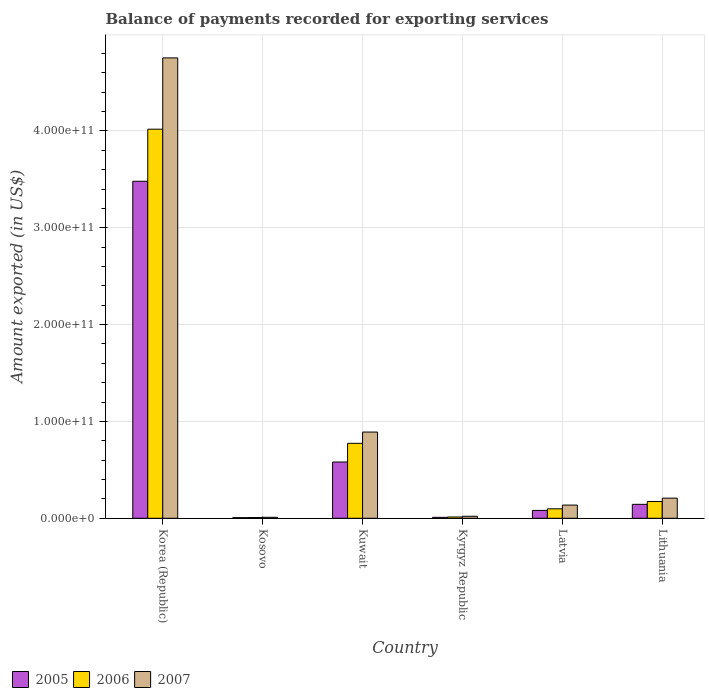How many different coloured bars are there?
Your answer should be compact. 3. Are the number of bars on each tick of the X-axis equal?
Keep it short and to the point. Yes. What is the label of the 3rd group of bars from the left?
Offer a very short reply. Kuwait. What is the amount exported in 2005 in Latvia?
Your response must be concise. 8.11e+09. Across all countries, what is the maximum amount exported in 2006?
Give a very brief answer. 4.02e+11. Across all countries, what is the minimum amount exported in 2006?
Your response must be concise. 7.50e+08. In which country was the amount exported in 2006 maximum?
Provide a succinct answer. Korea (Republic). In which country was the amount exported in 2007 minimum?
Your answer should be very brief. Kosovo. What is the total amount exported in 2006 in the graph?
Your answer should be compact. 5.08e+11. What is the difference between the amount exported in 2006 in Korea (Republic) and that in Lithuania?
Ensure brevity in your answer.  3.84e+11. What is the difference between the amount exported in 2006 in Kuwait and the amount exported in 2005 in Lithuania?
Ensure brevity in your answer.  6.30e+1. What is the average amount exported in 2007 per country?
Offer a very short reply. 1.00e+11. What is the difference between the amount exported of/in 2005 and amount exported of/in 2006 in Kosovo?
Keep it short and to the point. -1.26e+08. In how many countries, is the amount exported in 2005 greater than 300000000000 US$?
Provide a short and direct response. 1. What is the ratio of the amount exported in 2007 in Korea (Republic) to that in Latvia?
Provide a short and direct response. 34.93. Is the difference between the amount exported in 2005 in Korea (Republic) and Kuwait greater than the difference between the amount exported in 2006 in Korea (Republic) and Kuwait?
Ensure brevity in your answer.  No. What is the difference between the highest and the second highest amount exported in 2005?
Make the answer very short. 2.90e+11. What is the difference between the highest and the lowest amount exported in 2006?
Keep it short and to the point. 4.01e+11. In how many countries, is the amount exported in 2006 greater than the average amount exported in 2006 taken over all countries?
Provide a short and direct response. 1. Is the sum of the amount exported in 2007 in Korea (Republic) and Kyrgyz Republic greater than the maximum amount exported in 2006 across all countries?
Offer a terse response. Yes. What does the 3rd bar from the left in Kyrgyz Republic represents?
Give a very brief answer. 2007. What does the 2nd bar from the right in Kyrgyz Republic represents?
Give a very brief answer. 2006. How many countries are there in the graph?
Offer a terse response. 6. What is the difference between two consecutive major ticks on the Y-axis?
Give a very brief answer. 1.00e+11. Are the values on the major ticks of Y-axis written in scientific E-notation?
Your answer should be compact. Yes. Does the graph contain any zero values?
Your answer should be compact. No. Does the graph contain grids?
Offer a terse response. Yes. Where does the legend appear in the graph?
Provide a succinct answer. Bottom left. How many legend labels are there?
Your answer should be very brief. 3. What is the title of the graph?
Offer a very short reply. Balance of payments recorded for exporting services. Does "1990" appear as one of the legend labels in the graph?
Your response must be concise. No. What is the label or title of the Y-axis?
Keep it short and to the point. Amount exported (in US$). What is the Amount exported (in US$) of 2005 in Korea (Republic)?
Your answer should be very brief. 3.48e+11. What is the Amount exported (in US$) in 2006 in Korea (Republic)?
Your response must be concise. 4.02e+11. What is the Amount exported (in US$) in 2007 in Korea (Republic)?
Ensure brevity in your answer.  4.75e+11. What is the Amount exported (in US$) in 2005 in Kosovo?
Give a very brief answer. 6.25e+08. What is the Amount exported (in US$) of 2006 in Kosovo?
Make the answer very short. 7.50e+08. What is the Amount exported (in US$) of 2007 in Kosovo?
Make the answer very short. 9.91e+08. What is the Amount exported (in US$) of 2005 in Kuwait?
Offer a terse response. 5.81e+1. What is the Amount exported (in US$) in 2006 in Kuwait?
Your answer should be compact. 7.74e+1. What is the Amount exported (in US$) in 2007 in Kuwait?
Keep it short and to the point. 8.90e+1. What is the Amount exported (in US$) of 2005 in Kyrgyz Republic?
Make the answer very short. 9.63e+08. What is the Amount exported (in US$) in 2006 in Kyrgyz Republic?
Your answer should be compact. 1.33e+09. What is the Amount exported (in US$) in 2007 in Kyrgyz Republic?
Your answer should be compact. 2.07e+09. What is the Amount exported (in US$) in 2005 in Latvia?
Your answer should be compact. 8.11e+09. What is the Amount exported (in US$) of 2006 in Latvia?
Ensure brevity in your answer.  9.78e+09. What is the Amount exported (in US$) of 2007 in Latvia?
Your answer should be compact. 1.36e+1. What is the Amount exported (in US$) of 2005 in Lithuania?
Your answer should be very brief. 1.44e+1. What is the Amount exported (in US$) of 2006 in Lithuania?
Your response must be concise. 1.73e+1. What is the Amount exported (in US$) of 2007 in Lithuania?
Give a very brief answer. 2.08e+1. Across all countries, what is the maximum Amount exported (in US$) of 2005?
Keep it short and to the point. 3.48e+11. Across all countries, what is the maximum Amount exported (in US$) in 2006?
Offer a very short reply. 4.02e+11. Across all countries, what is the maximum Amount exported (in US$) of 2007?
Offer a terse response. 4.75e+11. Across all countries, what is the minimum Amount exported (in US$) in 2005?
Offer a terse response. 6.25e+08. Across all countries, what is the minimum Amount exported (in US$) of 2006?
Ensure brevity in your answer.  7.50e+08. Across all countries, what is the minimum Amount exported (in US$) of 2007?
Offer a very short reply. 9.91e+08. What is the total Amount exported (in US$) in 2005 in the graph?
Keep it short and to the point. 4.30e+11. What is the total Amount exported (in US$) of 2006 in the graph?
Offer a terse response. 5.08e+11. What is the total Amount exported (in US$) in 2007 in the graph?
Provide a short and direct response. 6.02e+11. What is the difference between the Amount exported (in US$) of 2005 in Korea (Republic) and that in Kosovo?
Give a very brief answer. 3.47e+11. What is the difference between the Amount exported (in US$) in 2006 in Korea (Republic) and that in Kosovo?
Your answer should be very brief. 4.01e+11. What is the difference between the Amount exported (in US$) of 2007 in Korea (Republic) and that in Kosovo?
Ensure brevity in your answer.  4.74e+11. What is the difference between the Amount exported (in US$) of 2005 in Korea (Republic) and that in Kuwait?
Your answer should be compact. 2.90e+11. What is the difference between the Amount exported (in US$) of 2006 in Korea (Republic) and that in Kuwait?
Your answer should be compact. 3.24e+11. What is the difference between the Amount exported (in US$) in 2007 in Korea (Republic) and that in Kuwait?
Make the answer very short. 3.86e+11. What is the difference between the Amount exported (in US$) in 2005 in Korea (Republic) and that in Kyrgyz Republic?
Keep it short and to the point. 3.47e+11. What is the difference between the Amount exported (in US$) in 2006 in Korea (Republic) and that in Kyrgyz Republic?
Offer a terse response. 4.00e+11. What is the difference between the Amount exported (in US$) in 2007 in Korea (Republic) and that in Kyrgyz Republic?
Your answer should be very brief. 4.73e+11. What is the difference between the Amount exported (in US$) of 2005 in Korea (Republic) and that in Latvia?
Your response must be concise. 3.40e+11. What is the difference between the Amount exported (in US$) in 2006 in Korea (Republic) and that in Latvia?
Ensure brevity in your answer.  3.92e+11. What is the difference between the Amount exported (in US$) of 2007 in Korea (Republic) and that in Latvia?
Offer a terse response. 4.62e+11. What is the difference between the Amount exported (in US$) of 2005 in Korea (Republic) and that in Lithuania?
Keep it short and to the point. 3.34e+11. What is the difference between the Amount exported (in US$) of 2006 in Korea (Republic) and that in Lithuania?
Offer a very short reply. 3.84e+11. What is the difference between the Amount exported (in US$) in 2007 in Korea (Republic) and that in Lithuania?
Give a very brief answer. 4.55e+11. What is the difference between the Amount exported (in US$) of 2005 in Kosovo and that in Kuwait?
Ensure brevity in your answer.  -5.75e+1. What is the difference between the Amount exported (in US$) in 2006 in Kosovo and that in Kuwait?
Provide a succinct answer. -7.66e+1. What is the difference between the Amount exported (in US$) of 2007 in Kosovo and that in Kuwait?
Ensure brevity in your answer.  -8.80e+1. What is the difference between the Amount exported (in US$) in 2005 in Kosovo and that in Kyrgyz Republic?
Your answer should be very brief. -3.38e+08. What is the difference between the Amount exported (in US$) of 2006 in Kosovo and that in Kyrgyz Republic?
Your answer should be compact. -5.76e+08. What is the difference between the Amount exported (in US$) in 2007 in Kosovo and that in Kyrgyz Republic?
Your answer should be compact. -1.07e+09. What is the difference between the Amount exported (in US$) in 2005 in Kosovo and that in Latvia?
Give a very brief answer. -7.49e+09. What is the difference between the Amount exported (in US$) of 2006 in Kosovo and that in Latvia?
Offer a terse response. -9.03e+09. What is the difference between the Amount exported (in US$) of 2007 in Kosovo and that in Latvia?
Provide a short and direct response. -1.26e+1. What is the difference between the Amount exported (in US$) of 2005 in Kosovo and that in Lithuania?
Your response must be concise. -1.38e+1. What is the difference between the Amount exported (in US$) in 2006 in Kosovo and that in Lithuania?
Your answer should be compact. -1.66e+1. What is the difference between the Amount exported (in US$) of 2007 in Kosovo and that in Lithuania?
Ensure brevity in your answer.  -1.98e+1. What is the difference between the Amount exported (in US$) in 2005 in Kuwait and that in Kyrgyz Republic?
Provide a short and direct response. 5.71e+1. What is the difference between the Amount exported (in US$) of 2006 in Kuwait and that in Kyrgyz Republic?
Ensure brevity in your answer.  7.61e+1. What is the difference between the Amount exported (in US$) of 2007 in Kuwait and that in Kyrgyz Republic?
Your answer should be very brief. 8.70e+1. What is the difference between the Amount exported (in US$) of 2005 in Kuwait and that in Latvia?
Offer a terse response. 5.00e+1. What is the difference between the Amount exported (in US$) in 2006 in Kuwait and that in Latvia?
Your answer should be compact. 6.76e+1. What is the difference between the Amount exported (in US$) in 2007 in Kuwait and that in Latvia?
Keep it short and to the point. 7.54e+1. What is the difference between the Amount exported (in US$) of 2005 in Kuwait and that in Lithuania?
Provide a succinct answer. 4.37e+1. What is the difference between the Amount exported (in US$) of 2006 in Kuwait and that in Lithuania?
Ensure brevity in your answer.  6.00e+1. What is the difference between the Amount exported (in US$) of 2007 in Kuwait and that in Lithuania?
Your answer should be very brief. 6.82e+1. What is the difference between the Amount exported (in US$) of 2005 in Kyrgyz Republic and that in Latvia?
Make the answer very short. -7.15e+09. What is the difference between the Amount exported (in US$) of 2006 in Kyrgyz Republic and that in Latvia?
Your answer should be compact. -8.45e+09. What is the difference between the Amount exported (in US$) of 2007 in Kyrgyz Republic and that in Latvia?
Provide a succinct answer. -1.15e+1. What is the difference between the Amount exported (in US$) in 2005 in Kyrgyz Republic and that in Lithuania?
Your response must be concise. -1.34e+1. What is the difference between the Amount exported (in US$) in 2006 in Kyrgyz Republic and that in Lithuania?
Ensure brevity in your answer.  -1.60e+1. What is the difference between the Amount exported (in US$) of 2007 in Kyrgyz Republic and that in Lithuania?
Give a very brief answer. -1.87e+1. What is the difference between the Amount exported (in US$) in 2005 in Latvia and that in Lithuania?
Your answer should be compact. -6.28e+09. What is the difference between the Amount exported (in US$) of 2006 in Latvia and that in Lithuania?
Provide a short and direct response. -7.57e+09. What is the difference between the Amount exported (in US$) of 2007 in Latvia and that in Lithuania?
Your response must be concise. -7.17e+09. What is the difference between the Amount exported (in US$) in 2005 in Korea (Republic) and the Amount exported (in US$) in 2006 in Kosovo?
Ensure brevity in your answer.  3.47e+11. What is the difference between the Amount exported (in US$) of 2005 in Korea (Republic) and the Amount exported (in US$) of 2007 in Kosovo?
Offer a terse response. 3.47e+11. What is the difference between the Amount exported (in US$) in 2006 in Korea (Republic) and the Amount exported (in US$) in 2007 in Kosovo?
Provide a succinct answer. 4.01e+11. What is the difference between the Amount exported (in US$) in 2005 in Korea (Republic) and the Amount exported (in US$) in 2006 in Kuwait?
Make the answer very short. 2.71e+11. What is the difference between the Amount exported (in US$) of 2005 in Korea (Republic) and the Amount exported (in US$) of 2007 in Kuwait?
Provide a succinct answer. 2.59e+11. What is the difference between the Amount exported (in US$) of 2006 in Korea (Republic) and the Amount exported (in US$) of 2007 in Kuwait?
Provide a short and direct response. 3.13e+11. What is the difference between the Amount exported (in US$) in 2005 in Korea (Republic) and the Amount exported (in US$) in 2006 in Kyrgyz Republic?
Make the answer very short. 3.47e+11. What is the difference between the Amount exported (in US$) in 2005 in Korea (Republic) and the Amount exported (in US$) in 2007 in Kyrgyz Republic?
Provide a succinct answer. 3.46e+11. What is the difference between the Amount exported (in US$) in 2006 in Korea (Republic) and the Amount exported (in US$) in 2007 in Kyrgyz Republic?
Your answer should be very brief. 4.00e+11. What is the difference between the Amount exported (in US$) of 2005 in Korea (Republic) and the Amount exported (in US$) of 2006 in Latvia?
Your response must be concise. 3.38e+11. What is the difference between the Amount exported (in US$) in 2005 in Korea (Republic) and the Amount exported (in US$) in 2007 in Latvia?
Your answer should be compact. 3.34e+11. What is the difference between the Amount exported (in US$) in 2006 in Korea (Republic) and the Amount exported (in US$) in 2007 in Latvia?
Offer a terse response. 3.88e+11. What is the difference between the Amount exported (in US$) of 2005 in Korea (Republic) and the Amount exported (in US$) of 2006 in Lithuania?
Your response must be concise. 3.31e+11. What is the difference between the Amount exported (in US$) of 2005 in Korea (Republic) and the Amount exported (in US$) of 2007 in Lithuania?
Your response must be concise. 3.27e+11. What is the difference between the Amount exported (in US$) in 2006 in Korea (Republic) and the Amount exported (in US$) in 2007 in Lithuania?
Your answer should be very brief. 3.81e+11. What is the difference between the Amount exported (in US$) in 2005 in Kosovo and the Amount exported (in US$) in 2006 in Kuwait?
Offer a terse response. -7.68e+1. What is the difference between the Amount exported (in US$) in 2005 in Kosovo and the Amount exported (in US$) in 2007 in Kuwait?
Keep it short and to the point. -8.84e+1. What is the difference between the Amount exported (in US$) of 2006 in Kosovo and the Amount exported (in US$) of 2007 in Kuwait?
Provide a succinct answer. -8.83e+1. What is the difference between the Amount exported (in US$) of 2005 in Kosovo and the Amount exported (in US$) of 2006 in Kyrgyz Republic?
Provide a short and direct response. -7.02e+08. What is the difference between the Amount exported (in US$) of 2005 in Kosovo and the Amount exported (in US$) of 2007 in Kyrgyz Republic?
Give a very brief answer. -1.44e+09. What is the difference between the Amount exported (in US$) of 2006 in Kosovo and the Amount exported (in US$) of 2007 in Kyrgyz Republic?
Make the answer very short. -1.31e+09. What is the difference between the Amount exported (in US$) in 2005 in Kosovo and the Amount exported (in US$) in 2006 in Latvia?
Offer a very short reply. -9.16e+09. What is the difference between the Amount exported (in US$) of 2005 in Kosovo and the Amount exported (in US$) of 2007 in Latvia?
Keep it short and to the point. -1.30e+1. What is the difference between the Amount exported (in US$) of 2006 in Kosovo and the Amount exported (in US$) of 2007 in Latvia?
Ensure brevity in your answer.  -1.29e+1. What is the difference between the Amount exported (in US$) in 2005 in Kosovo and the Amount exported (in US$) in 2006 in Lithuania?
Your answer should be very brief. -1.67e+1. What is the difference between the Amount exported (in US$) of 2005 in Kosovo and the Amount exported (in US$) of 2007 in Lithuania?
Provide a succinct answer. -2.02e+1. What is the difference between the Amount exported (in US$) in 2006 in Kosovo and the Amount exported (in US$) in 2007 in Lithuania?
Provide a short and direct response. -2.00e+1. What is the difference between the Amount exported (in US$) of 2005 in Kuwait and the Amount exported (in US$) of 2006 in Kyrgyz Republic?
Your response must be concise. 5.68e+1. What is the difference between the Amount exported (in US$) of 2005 in Kuwait and the Amount exported (in US$) of 2007 in Kyrgyz Republic?
Your answer should be very brief. 5.60e+1. What is the difference between the Amount exported (in US$) of 2006 in Kuwait and the Amount exported (in US$) of 2007 in Kyrgyz Republic?
Offer a terse response. 7.53e+1. What is the difference between the Amount exported (in US$) of 2005 in Kuwait and the Amount exported (in US$) of 2006 in Latvia?
Provide a short and direct response. 4.83e+1. What is the difference between the Amount exported (in US$) of 2005 in Kuwait and the Amount exported (in US$) of 2007 in Latvia?
Provide a succinct answer. 4.45e+1. What is the difference between the Amount exported (in US$) of 2006 in Kuwait and the Amount exported (in US$) of 2007 in Latvia?
Offer a very short reply. 6.38e+1. What is the difference between the Amount exported (in US$) in 2005 in Kuwait and the Amount exported (in US$) in 2006 in Lithuania?
Give a very brief answer. 4.08e+1. What is the difference between the Amount exported (in US$) of 2005 in Kuwait and the Amount exported (in US$) of 2007 in Lithuania?
Offer a terse response. 3.73e+1. What is the difference between the Amount exported (in US$) of 2006 in Kuwait and the Amount exported (in US$) of 2007 in Lithuania?
Your answer should be compact. 5.66e+1. What is the difference between the Amount exported (in US$) in 2005 in Kyrgyz Republic and the Amount exported (in US$) in 2006 in Latvia?
Ensure brevity in your answer.  -8.82e+09. What is the difference between the Amount exported (in US$) in 2005 in Kyrgyz Republic and the Amount exported (in US$) in 2007 in Latvia?
Provide a short and direct response. -1.26e+1. What is the difference between the Amount exported (in US$) in 2006 in Kyrgyz Republic and the Amount exported (in US$) in 2007 in Latvia?
Your response must be concise. -1.23e+1. What is the difference between the Amount exported (in US$) of 2005 in Kyrgyz Republic and the Amount exported (in US$) of 2006 in Lithuania?
Provide a succinct answer. -1.64e+1. What is the difference between the Amount exported (in US$) of 2005 in Kyrgyz Republic and the Amount exported (in US$) of 2007 in Lithuania?
Ensure brevity in your answer.  -1.98e+1. What is the difference between the Amount exported (in US$) of 2006 in Kyrgyz Republic and the Amount exported (in US$) of 2007 in Lithuania?
Ensure brevity in your answer.  -1.95e+1. What is the difference between the Amount exported (in US$) in 2005 in Latvia and the Amount exported (in US$) in 2006 in Lithuania?
Offer a very short reply. -9.24e+09. What is the difference between the Amount exported (in US$) of 2005 in Latvia and the Amount exported (in US$) of 2007 in Lithuania?
Offer a very short reply. -1.27e+1. What is the difference between the Amount exported (in US$) in 2006 in Latvia and the Amount exported (in US$) in 2007 in Lithuania?
Offer a terse response. -1.10e+1. What is the average Amount exported (in US$) in 2005 per country?
Your response must be concise. 7.17e+1. What is the average Amount exported (in US$) in 2006 per country?
Ensure brevity in your answer.  8.47e+1. What is the average Amount exported (in US$) in 2007 per country?
Your answer should be very brief. 1.00e+11. What is the difference between the Amount exported (in US$) of 2005 and Amount exported (in US$) of 2006 in Korea (Republic)?
Provide a short and direct response. -5.38e+1. What is the difference between the Amount exported (in US$) of 2005 and Amount exported (in US$) of 2007 in Korea (Republic)?
Ensure brevity in your answer.  -1.27e+11. What is the difference between the Amount exported (in US$) in 2006 and Amount exported (in US$) in 2007 in Korea (Republic)?
Keep it short and to the point. -7.36e+1. What is the difference between the Amount exported (in US$) in 2005 and Amount exported (in US$) in 2006 in Kosovo?
Offer a terse response. -1.26e+08. What is the difference between the Amount exported (in US$) of 2005 and Amount exported (in US$) of 2007 in Kosovo?
Provide a succinct answer. -3.66e+08. What is the difference between the Amount exported (in US$) of 2006 and Amount exported (in US$) of 2007 in Kosovo?
Provide a succinct answer. -2.40e+08. What is the difference between the Amount exported (in US$) in 2005 and Amount exported (in US$) in 2006 in Kuwait?
Make the answer very short. -1.93e+1. What is the difference between the Amount exported (in US$) of 2005 and Amount exported (in US$) of 2007 in Kuwait?
Offer a very short reply. -3.09e+1. What is the difference between the Amount exported (in US$) of 2006 and Amount exported (in US$) of 2007 in Kuwait?
Your answer should be very brief. -1.16e+1. What is the difference between the Amount exported (in US$) in 2005 and Amount exported (in US$) in 2006 in Kyrgyz Republic?
Make the answer very short. -3.64e+08. What is the difference between the Amount exported (in US$) of 2005 and Amount exported (in US$) of 2007 in Kyrgyz Republic?
Keep it short and to the point. -1.10e+09. What is the difference between the Amount exported (in US$) of 2006 and Amount exported (in US$) of 2007 in Kyrgyz Republic?
Make the answer very short. -7.39e+08. What is the difference between the Amount exported (in US$) of 2005 and Amount exported (in US$) of 2006 in Latvia?
Make the answer very short. -1.67e+09. What is the difference between the Amount exported (in US$) in 2005 and Amount exported (in US$) in 2007 in Latvia?
Provide a succinct answer. -5.50e+09. What is the difference between the Amount exported (in US$) in 2006 and Amount exported (in US$) in 2007 in Latvia?
Provide a short and direct response. -3.83e+09. What is the difference between the Amount exported (in US$) of 2005 and Amount exported (in US$) of 2006 in Lithuania?
Keep it short and to the point. -2.96e+09. What is the difference between the Amount exported (in US$) of 2005 and Amount exported (in US$) of 2007 in Lithuania?
Make the answer very short. -6.39e+09. What is the difference between the Amount exported (in US$) of 2006 and Amount exported (in US$) of 2007 in Lithuania?
Give a very brief answer. -3.43e+09. What is the ratio of the Amount exported (in US$) of 2005 in Korea (Republic) to that in Kosovo?
Your answer should be compact. 556.95. What is the ratio of the Amount exported (in US$) of 2006 in Korea (Republic) to that in Kosovo?
Your answer should be compact. 535.36. What is the ratio of the Amount exported (in US$) in 2007 in Korea (Republic) to that in Kosovo?
Offer a terse response. 479.9. What is the ratio of the Amount exported (in US$) of 2005 in Korea (Republic) to that in Kuwait?
Your answer should be compact. 5.99. What is the ratio of the Amount exported (in US$) in 2006 in Korea (Republic) to that in Kuwait?
Your response must be concise. 5.19. What is the ratio of the Amount exported (in US$) of 2007 in Korea (Republic) to that in Kuwait?
Make the answer very short. 5.34. What is the ratio of the Amount exported (in US$) in 2005 in Korea (Republic) to that in Kyrgyz Republic?
Your answer should be very brief. 361.44. What is the ratio of the Amount exported (in US$) of 2006 in Korea (Republic) to that in Kyrgyz Republic?
Ensure brevity in your answer.  302.91. What is the ratio of the Amount exported (in US$) of 2007 in Korea (Republic) to that in Kyrgyz Republic?
Ensure brevity in your answer.  230.19. What is the ratio of the Amount exported (in US$) of 2005 in Korea (Republic) to that in Latvia?
Your answer should be very brief. 42.9. What is the ratio of the Amount exported (in US$) in 2006 in Korea (Republic) to that in Latvia?
Keep it short and to the point. 41.08. What is the ratio of the Amount exported (in US$) in 2007 in Korea (Republic) to that in Latvia?
Make the answer very short. 34.93. What is the ratio of the Amount exported (in US$) of 2005 in Korea (Republic) to that in Lithuania?
Your answer should be compact. 24.19. What is the ratio of the Amount exported (in US$) of 2006 in Korea (Republic) to that in Lithuania?
Provide a short and direct response. 23.16. What is the ratio of the Amount exported (in US$) in 2007 in Korea (Republic) to that in Lithuania?
Give a very brief answer. 22.88. What is the ratio of the Amount exported (in US$) in 2005 in Kosovo to that in Kuwait?
Give a very brief answer. 0.01. What is the ratio of the Amount exported (in US$) in 2006 in Kosovo to that in Kuwait?
Your answer should be compact. 0.01. What is the ratio of the Amount exported (in US$) of 2007 in Kosovo to that in Kuwait?
Keep it short and to the point. 0.01. What is the ratio of the Amount exported (in US$) of 2005 in Kosovo to that in Kyrgyz Republic?
Make the answer very short. 0.65. What is the ratio of the Amount exported (in US$) in 2006 in Kosovo to that in Kyrgyz Republic?
Offer a very short reply. 0.57. What is the ratio of the Amount exported (in US$) of 2007 in Kosovo to that in Kyrgyz Republic?
Provide a succinct answer. 0.48. What is the ratio of the Amount exported (in US$) of 2005 in Kosovo to that in Latvia?
Offer a terse response. 0.08. What is the ratio of the Amount exported (in US$) of 2006 in Kosovo to that in Latvia?
Provide a short and direct response. 0.08. What is the ratio of the Amount exported (in US$) of 2007 in Kosovo to that in Latvia?
Provide a short and direct response. 0.07. What is the ratio of the Amount exported (in US$) in 2005 in Kosovo to that in Lithuania?
Your answer should be very brief. 0.04. What is the ratio of the Amount exported (in US$) in 2006 in Kosovo to that in Lithuania?
Provide a succinct answer. 0.04. What is the ratio of the Amount exported (in US$) of 2007 in Kosovo to that in Lithuania?
Your answer should be compact. 0.05. What is the ratio of the Amount exported (in US$) of 2005 in Kuwait to that in Kyrgyz Republic?
Provide a succinct answer. 60.35. What is the ratio of the Amount exported (in US$) of 2006 in Kuwait to that in Kyrgyz Republic?
Provide a short and direct response. 58.35. What is the ratio of the Amount exported (in US$) in 2007 in Kuwait to that in Kyrgyz Republic?
Your answer should be compact. 43.1. What is the ratio of the Amount exported (in US$) in 2005 in Kuwait to that in Latvia?
Provide a succinct answer. 7.16. What is the ratio of the Amount exported (in US$) in 2006 in Kuwait to that in Latvia?
Keep it short and to the point. 7.91. What is the ratio of the Amount exported (in US$) in 2007 in Kuwait to that in Latvia?
Ensure brevity in your answer.  6.54. What is the ratio of the Amount exported (in US$) in 2005 in Kuwait to that in Lithuania?
Give a very brief answer. 4.04. What is the ratio of the Amount exported (in US$) of 2006 in Kuwait to that in Lithuania?
Provide a short and direct response. 4.46. What is the ratio of the Amount exported (in US$) of 2007 in Kuwait to that in Lithuania?
Your answer should be compact. 4.28. What is the ratio of the Amount exported (in US$) of 2005 in Kyrgyz Republic to that in Latvia?
Ensure brevity in your answer.  0.12. What is the ratio of the Amount exported (in US$) of 2006 in Kyrgyz Republic to that in Latvia?
Provide a short and direct response. 0.14. What is the ratio of the Amount exported (in US$) in 2007 in Kyrgyz Republic to that in Latvia?
Your response must be concise. 0.15. What is the ratio of the Amount exported (in US$) of 2005 in Kyrgyz Republic to that in Lithuania?
Provide a short and direct response. 0.07. What is the ratio of the Amount exported (in US$) in 2006 in Kyrgyz Republic to that in Lithuania?
Offer a very short reply. 0.08. What is the ratio of the Amount exported (in US$) of 2007 in Kyrgyz Republic to that in Lithuania?
Provide a short and direct response. 0.1. What is the ratio of the Amount exported (in US$) of 2005 in Latvia to that in Lithuania?
Provide a succinct answer. 0.56. What is the ratio of the Amount exported (in US$) in 2006 in Latvia to that in Lithuania?
Give a very brief answer. 0.56. What is the ratio of the Amount exported (in US$) of 2007 in Latvia to that in Lithuania?
Your response must be concise. 0.65. What is the difference between the highest and the second highest Amount exported (in US$) in 2005?
Make the answer very short. 2.90e+11. What is the difference between the highest and the second highest Amount exported (in US$) of 2006?
Keep it short and to the point. 3.24e+11. What is the difference between the highest and the second highest Amount exported (in US$) of 2007?
Provide a succinct answer. 3.86e+11. What is the difference between the highest and the lowest Amount exported (in US$) of 2005?
Your answer should be very brief. 3.47e+11. What is the difference between the highest and the lowest Amount exported (in US$) of 2006?
Give a very brief answer. 4.01e+11. What is the difference between the highest and the lowest Amount exported (in US$) in 2007?
Provide a short and direct response. 4.74e+11. 